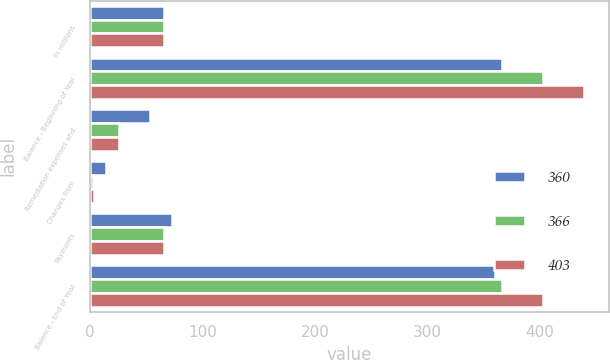Convert chart. <chart><loc_0><loc_0><loc_500><loc_500><stacked_bar_chart><ecel><fcel>In millions<fcel>Balance - Beginning of Year<fcel>Remediation expenses and<fcel>Changes from<fcel>Payments<fcel>Balance - End of Year<nl><fcel>360<fcel>66<fcel>366<fcel>53<fcel>14<fcel>73<fcel>360<nl><fcel>366<fcel>66<fcel>403<fcel>26<fcel>3<fcel>66<fcel>366<nl><fcel>403<fcel>66<fcel>439<fcel>26<fcel>4<fcel>66<fcel>403<nl></chart> 